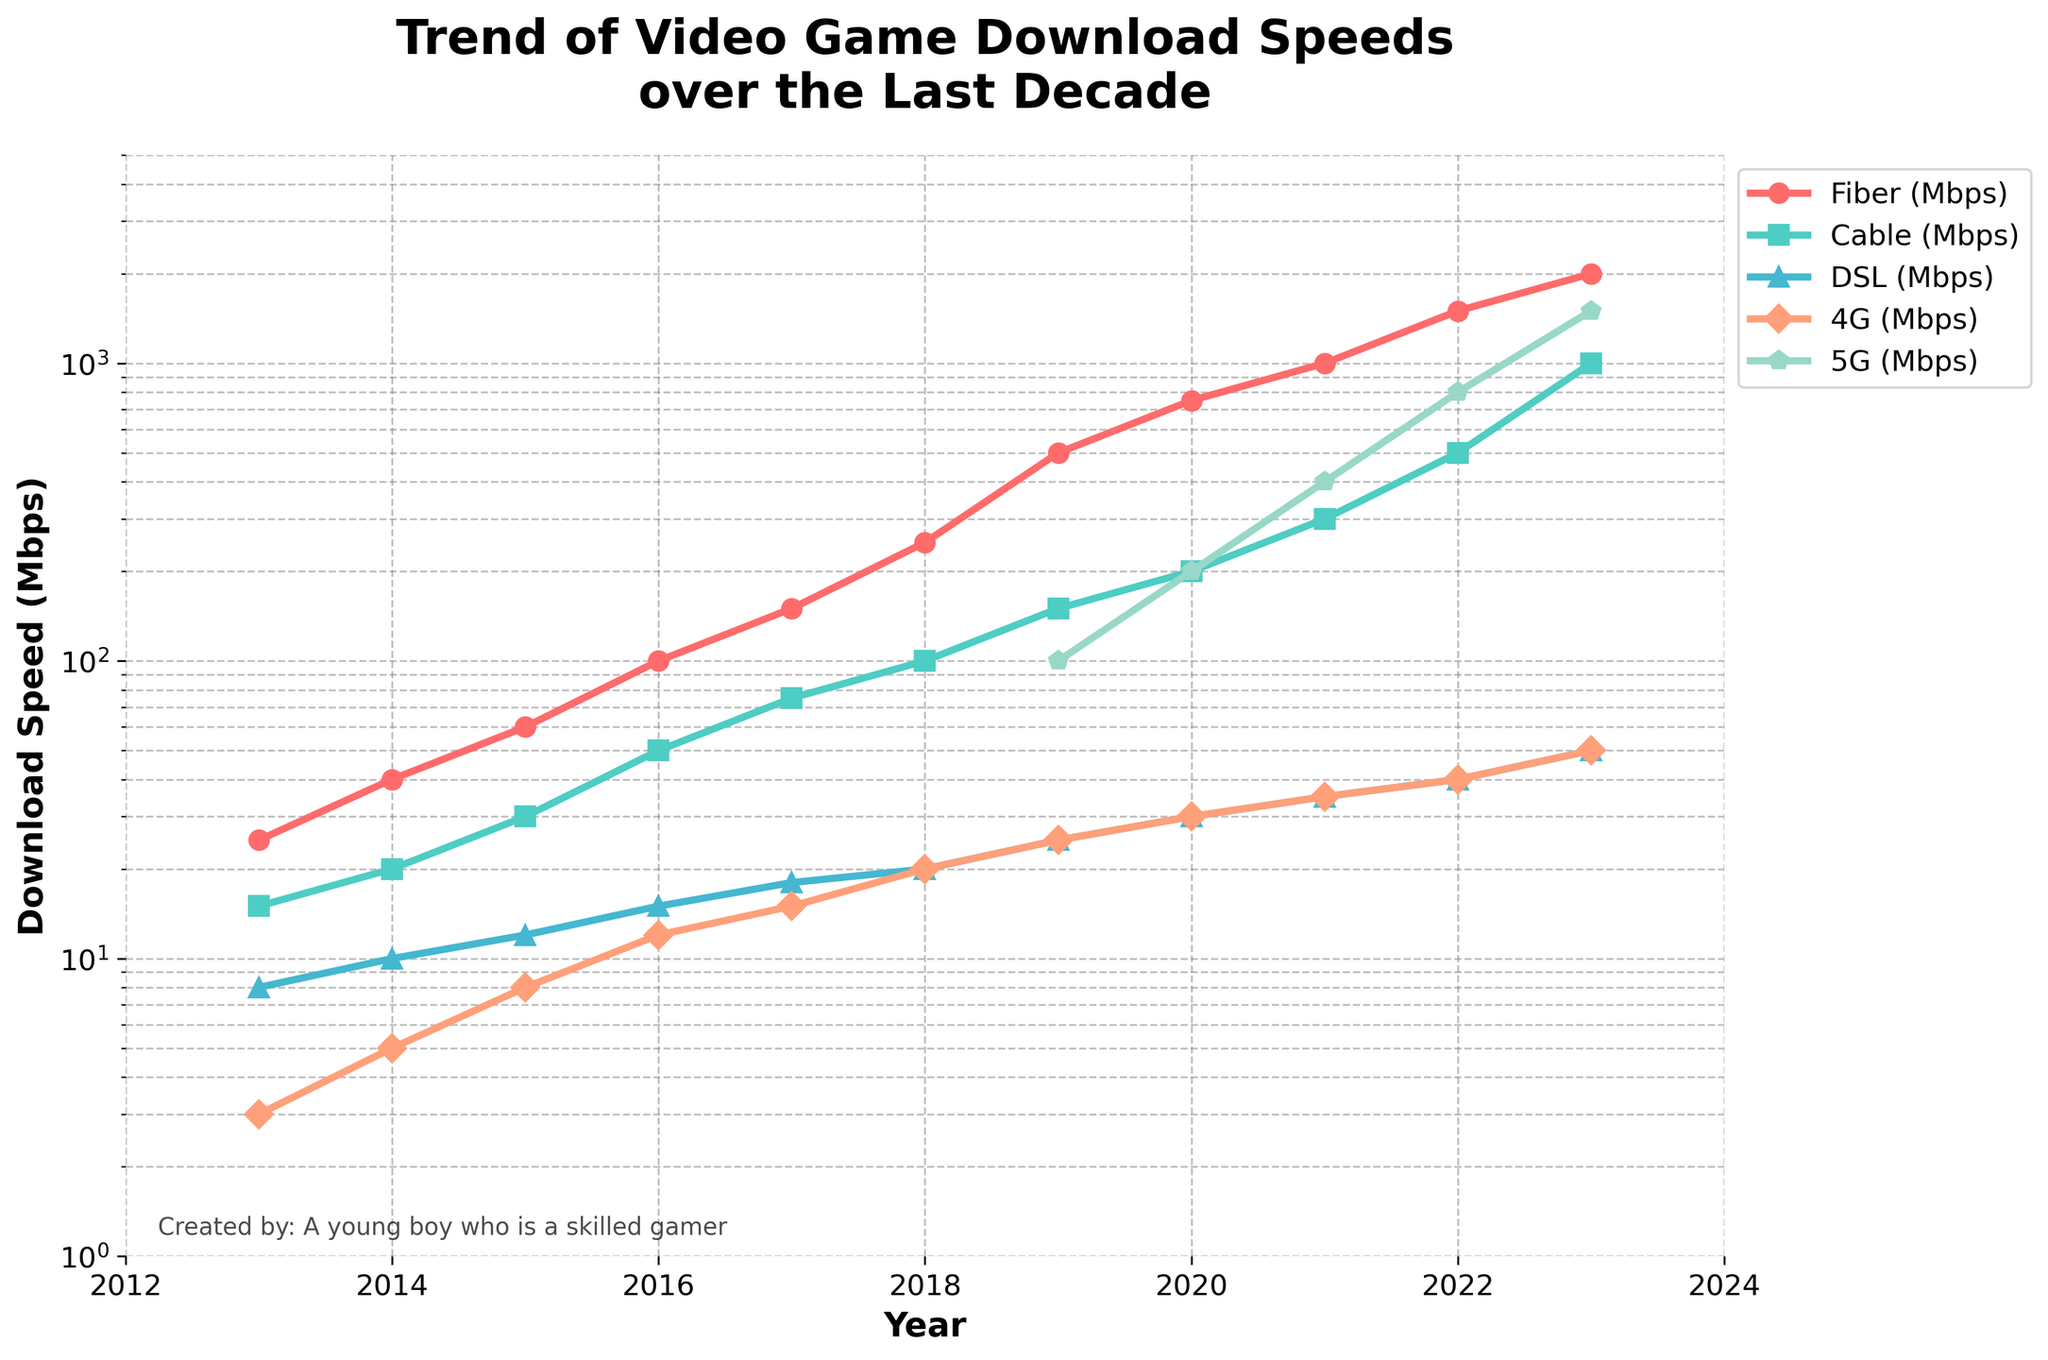what year did 5G speeds surpass 4G speeds for the first time? According to the plot, 5G speeds are first visible in 2019. From this year on, the 5G speed is higher than the 4G speed in all subsequent years.
Answer: 2019 what is the range of download speeds for Fiber over the decade covered by the figure? The range is calculated by subtracting the minimum download speed for Fiber from the maximum download speed. The minimum speed is 25 Mbps in 2013, and the maximum speed is 2000 Mbps in 2023. Thus, the range is 2000 - 25 = 1975 Mbps.
Answer: 1975 Mbps how much faster was the download speed for Cable in 2023 compared to 2013? In 2023, the download speed for Cable is 1000 Mbps, and in 2013, it was 15 Mbps. To find the difference, subtract the 2013 speed from the 2023 speed: 1000 - 15 = 985 Mbps.
Answer: 985 Mbps which type of connection showed the greatest improvement in download speeds from 2013 to 2023? The improvement is greatest for Fiber, which increased from 25 Mbps in 2013 to 2000 Mbps in 2023. The improvement can be calculated as 2000 - 25 = 1975 Mbps.
Answer: Fiber what is the download speed of Fiber compared to Cable in 2023? The download speed for Fiber in 2023 is 2000 Mbps, and for Cable, it is 1000 Mbps. Comparing these two, Fiber is twice as fast as Cable in 2023.
Answer: Twice as fast what is the average download speed for 4G in the years it was tracked? The download speeds for 4G from 2013 to 2023 are: 3, 5, 8, 12, 15, 20, 25, 30, 35, 40, and 50 Mbps. Sum these speeds (3 + 5 + 8 + 12 + 15 + 20 + 25 + 30 + 35 + 40 + 50 = 243) and divide by the number of years tracked (11). The average speed is 243 / 11 ≈ 22 Mbps.
Answer: Approximately 22 Mbps which year did DSL first exceed 30 Mbps in download speed? From the plot, DSL download speeds are first shown exceeding 30 Mbps in 2020 with a speed of 30 Mbps.
Answer: 2020 how does the download speed for 5G in 2023 compare to that for Fiber in 2016? The download speed for 5G in 2023 is 1500 Mbps, and the Fiber download speed in 2016 is 100 Mbps. Comparing these two, 5G in 2023 is 15 times faster than Fiber was in 2016.
Answer: 15 times faster 